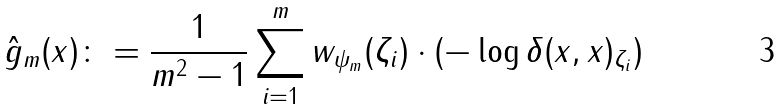Convert formula to latex. <formula><loc_0><loc_0><loc_500><loc_500>\hat { g } _ { m } ( x ) \colon = \frac { 1 } { m ^ { 2 } - 1 } \sum _ { i = 1 } ^ { m } w _ { \psi _ { m } } ( \zeta _ { i } ) \cdot ( - \log \delta ( x , x ) _ { \zeta _ { i } } )</formula> 